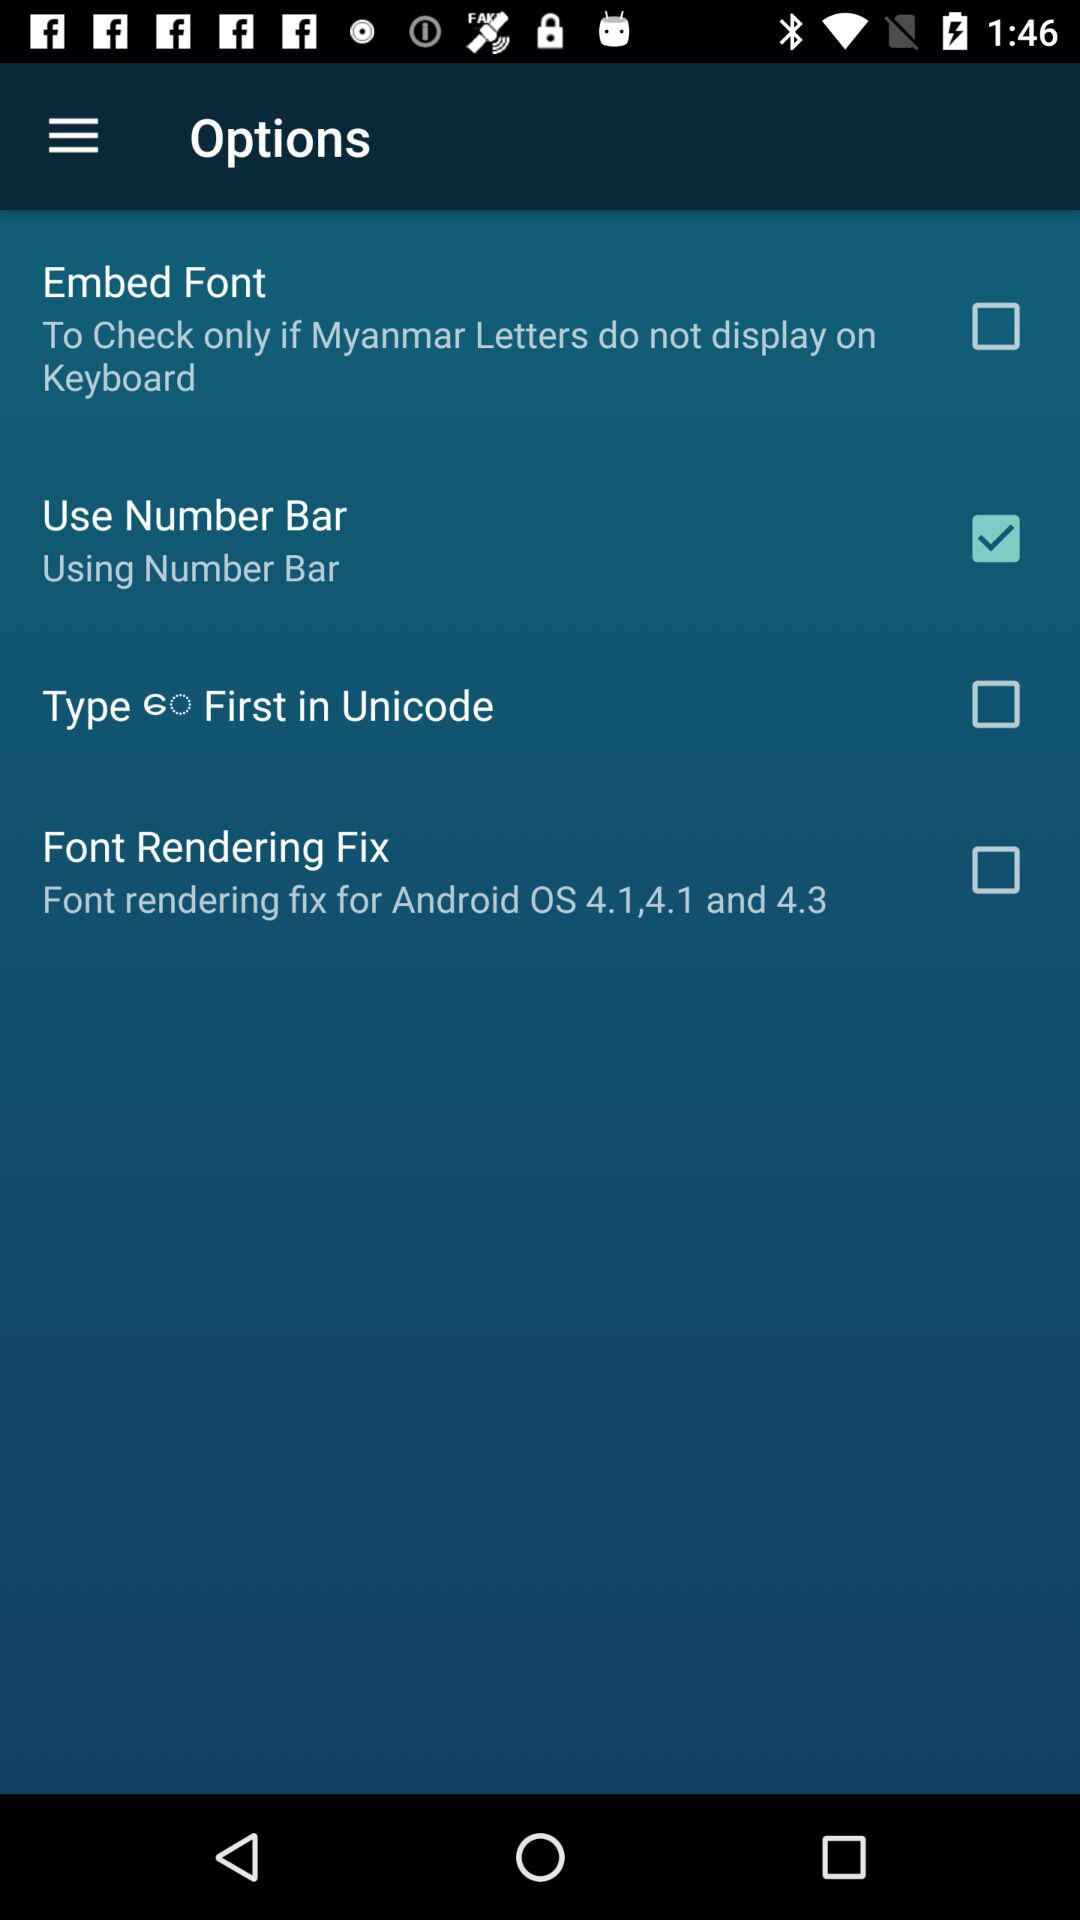What is the status of "Use Number Bar"? The status is "on". 